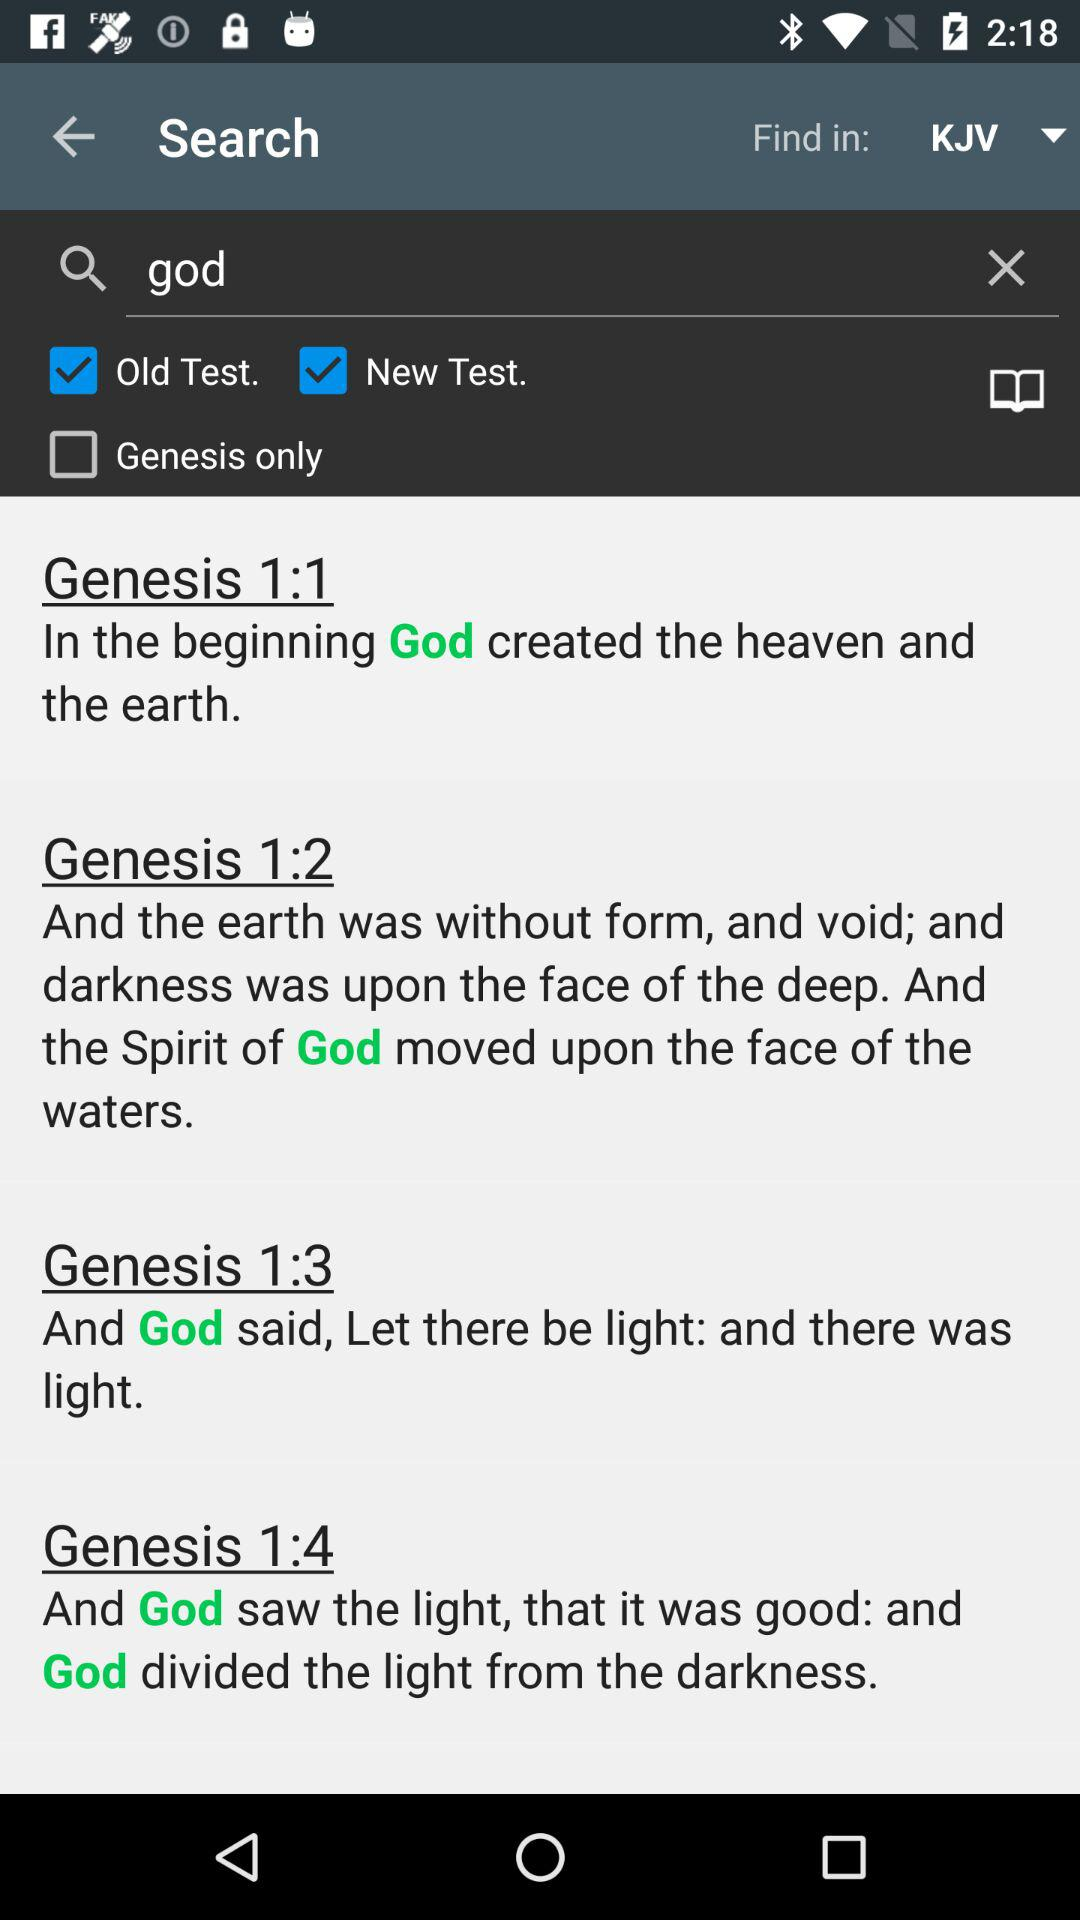Which options are checked? The checked options are "Old Test." and "New Test.". 